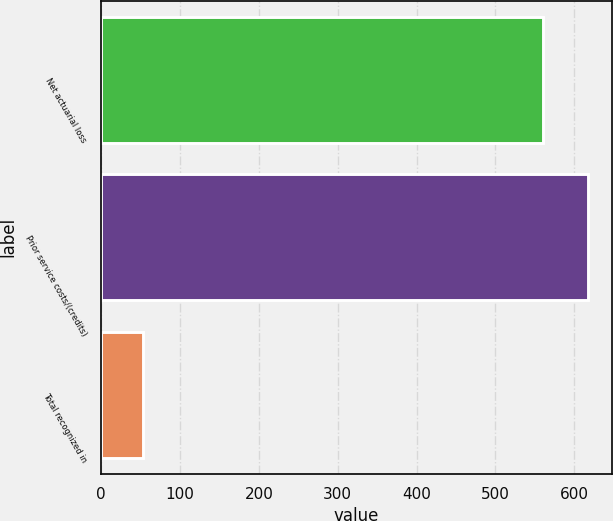Convert chart. <chart><loc_0><loc_0><loc_500><loc_500><bar_chart><fcel>Net actuarial loss<fcel>Prior service costs/(credits)<fcel>Total recognized in<nl><fcel>561<fcel>617.1<fcel>53<nl></chart> 